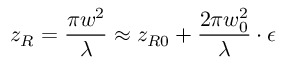Convert formula to latex. <formula><loc_0><loc_0><loc_500><loc_500>z _ { R } = \frac { \pi w ^ { 2 } } { \lambda } \approx z _ { R 0 } + \frac { 2 \pi w _ { 0 } ^ { 2 } } { \lambda } \cdot \epsilon</formula> 